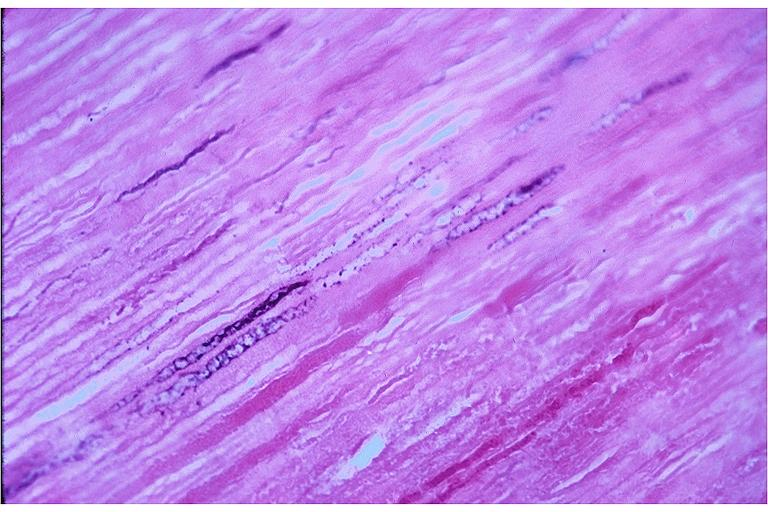s oral present?
Answer the question using a single word or phrase. Yes 